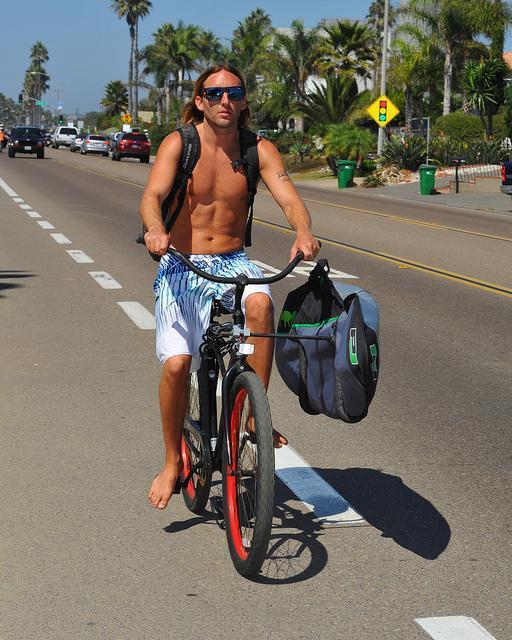How many bike shadows are there?
Give a very brief answer. 1. How many backpacks can be seen?
Give a very brief answer. 2. 